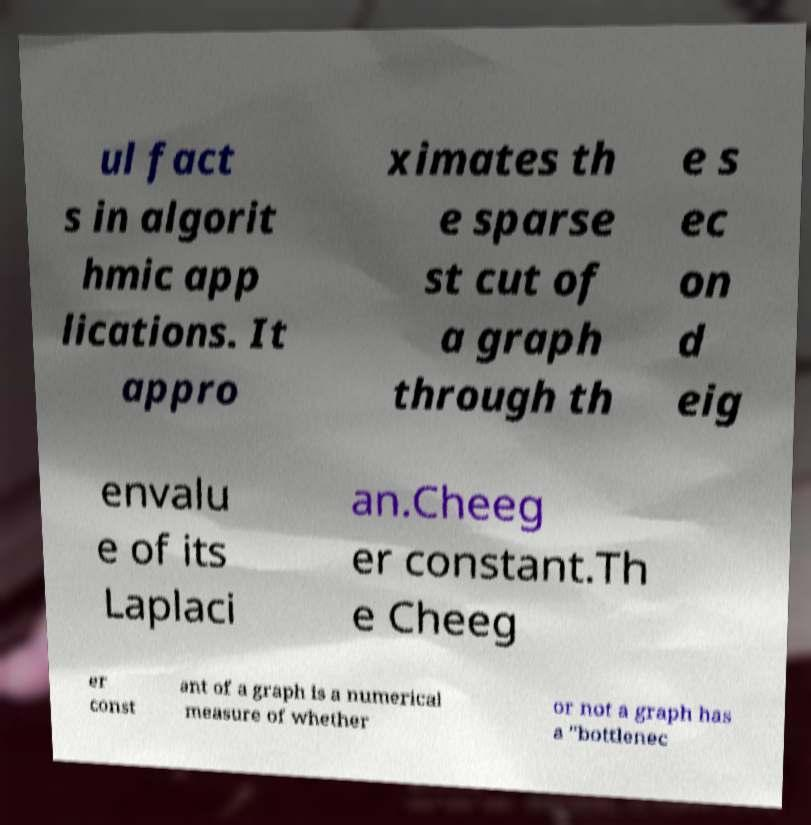There's text embedded in this image that I need extracted. Can you transcribe it verbatim? ul fact s in algorit hmic app lications. It appro ximates th e sparse st cut of a graph through th e s ec on d eig envalu e of its Laplaci an.Cheeg er constant.Th e Cheeg er const ant of a graph is a numerical measure of whether or not a graph has a "bottlenec 